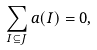<formula> <loc_0><loc_0><loc_500><loc_500>\sum _ { I \subseteq J } a ( I ) = 0 ,</formula> 